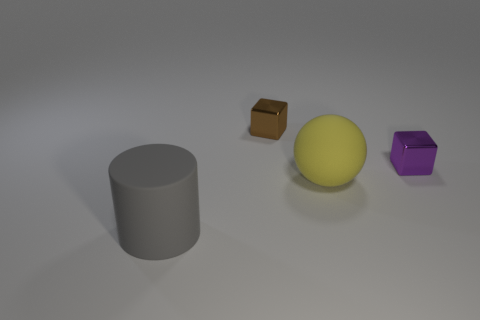What is the shape of the gray thing that is made of the same material as the ball?
Provide a short and direct response. Cylinder. Are there any other things that have the same color as the cylinder?
Give a very brief answer. No. The big thing that is to the right of the gray cylinder is what color?
Ensure brevity in your answer.  Yellow. Is the color of the metal object that is right of the yellow rubber ball the same as the large matte sphere?
Make the answer very short. No. There is another thing that is the same shape as the small purple metal object; what is its material?
Make the answer very short. Metal. What number of yellow rubber balls have the same size as the gray rubber cylinder?
Keep it short and to the point. 1. The large gray object has what shape?
Your answer should be very brief. Cylinder. There is a thing that is both behind the gray matte object and left of the yellow matte sphere; what size is it?
Your response must be concise. Small. What is the thing that is in front of the yellow rubber sphere made of?
Offer a very short reply. Rubber. Do the ball and the metallic thing that is in front of the brown metallic cube have the same color?
Give a very brief answer. No. 